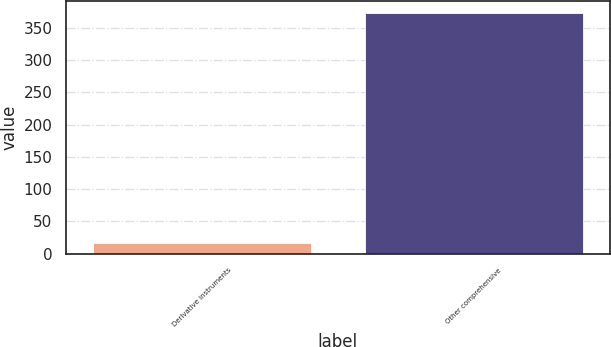<chart> <loc_0><loc_0><loc_500><loc_500><bar_chart><fcel>Derivative instruments<fcel>Other comprehensive<nl><fcel>17<fcel>373<nl></chart> 